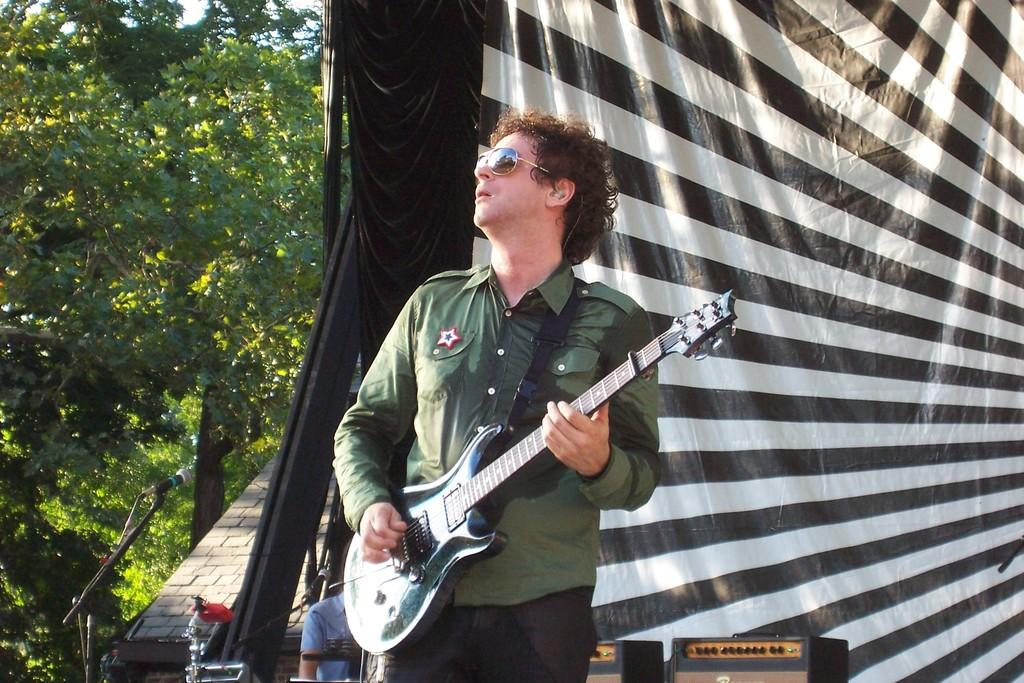What is the man in the image doing? The man is playing a guitar in the image. What can be seen in the background of the image? There are trees visible in the image. What object is present that might be used for amplifying the man's voice? There is a microphone in the image. How many straws are being used by the dogs in the image? There are no dogs or straws present in the image. What type of space vehicle can be seen in the image? There is no space vehicle present in the image. 